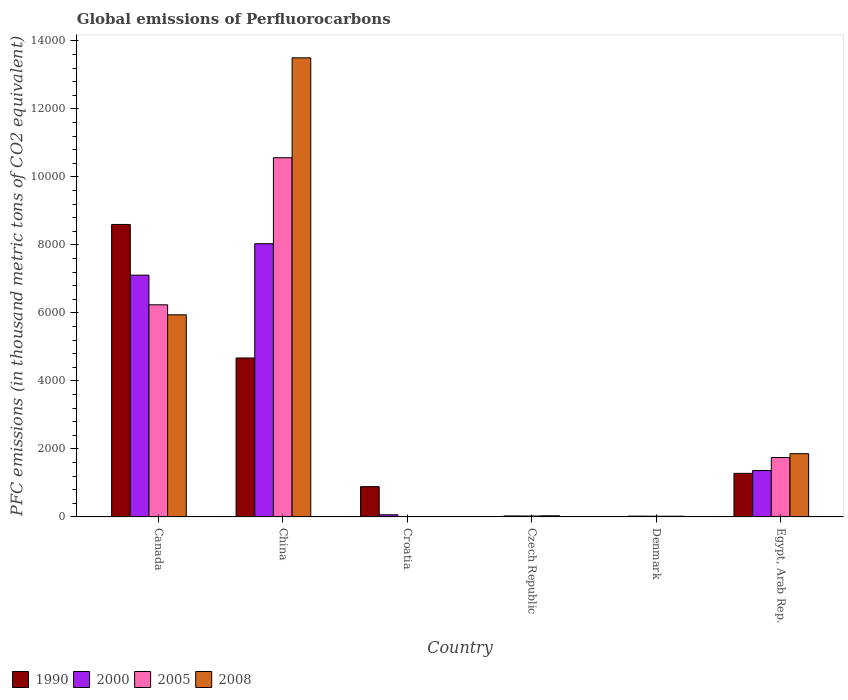How many bars are there on the 3rd tick from the right?
Offer a terse response. 4. What is the label of the 3rd group of bars from the left?
Offer a terse response. Croatia. What is the global emissions of Perfluorocarbons in 1990 in Denmark?
Your response must be concise. 1.4. Across all countries, what is the maximum global emissions of Perfluorocarbons in 2008?
Ensure brevity in your answer.  1.35e+04. In which country was the global emissions of Perfluorocarbons in 2008 minimum?
Offer a very short reply. Croatia. What is the total global emissions of Perfluorocarbons in 2005 in the graph?
Give a very brief answer. 1.86e+04. What is the difference between the global emissions of Perfluorocarbons in 2008 in Croatia and that in Egypt, Arab Rep.?
Your response must be concise. -1848.8. What is the difference between the global emissions of Perfluorocarbons in 2000 in Czech Republic and the global emissions of Perfluorocarbons in 2005 in Egypt, Arab Rep.?
Provide a short and direct response. -1718.3. What is the average global emissions of Perfluorocarbons in 2005 per country?
Your answer should be compact. 3101.3. What is the ratio of the global emissions of Perfluorocarbons in 1990 in Croatia to that in Egypt, Arab Rep.?
Ensure brevity in your answer.  0.7. Is the difference between the global emissions of Perfluorocarbons in 2008 in China and Croatia greater than the difference between the global emissions of Perfluorocarbons in 2000 in China and Croatia?
Provide a succinct answer. Yes. What is the difference between the highest and the second highest global emissions of Perfluorocarbons in 2000?
Your response must be concise. 6670.6. What is the difference between the highest and the lowest global emissions of Perfluorocarbons in 2005?
Provide a short and direct response. 1.06e+04. Is the sum of the global emissions of Perfluorocarbons in 2000 in Czech Republic and Egypt, Arab Rep. greater than the maximum global emissions of Perfluorocarbons in 2005 across all countries?
Keep it short and to the point. No. Is it the case that in every country, the sum of the global emissions of Perfluorocarbons in 2000 and global emissions of Perfluorocarbons in 2008 is greater than the sum of global emissions of Perfluorocarbons in 2005 and global emissions of Perfluorocarbons in 1990?
Your answer should be compact. No. What does the 2nd bar from the right in Denmark represents?
Your response must be concise. 2005. Is it the case that in every country, the sum of the global emissions of Perfluorocarbons in 2005 and global emissions of Perfluorocarbons in 2000 is greater than the global emissions of Perfluorocarbons in 2008?
Provide a short and direct response. Yes. How many bars are there?
Make the answer very short. 24. What is the difference between two consecutive major ticks on the Y-axis?
Ensure brevity in your answer.  2000. Are the values on the major ticks of Y-axis written in scientific E-notation?
Ensure brevity in your answer.  No. Does the graph contain any zero values?
Provide a succinct answer. No. Where does the legend appear in the graph?
Your answer should be very brief. Bottom left. What is the title of the graph?
Provide a succinct answer. Global emissions of Perfluorocarbons. Does "1978" appear as one of the legend labels in the graph?
Give a very brief answer. No. What is the label or title of the Y-axis?
Ensure brevity in your answer.  PFC emissions (in thousand metric tons of CO2 equivalent). What is the PFC emissions (in thousand metric tons of CO2 equivalent) of 1990 in Canada?
Offer a terse response. 8600.3. What is the PFC emissions (in thousand metric tons of CO2 equivalent) of 2000 in Canada?
Provide a short and direct response. 7109.9. What is the PFC emissions (in thousand metric tons of CO2 equivalent) of 2005 in Canada?
Your response must be concise. 6238. What is the PFC emissions (in thousand metric tons of CO2 equivalent) of 2008 in Canada?
Keep it short and to the point. 5943.7. What is the PFC emissions (in thousand metric tons of CO2 equivalent) of 1990 in China?
Ensure brevity in your answer.  4674.5. What is the PFC emissions (in thousand metric tons of CO2 equivalent) in 2000 in China?
Provide a succinct answer. 8034.4. What is the PFC emissions (in thousand metric tons of CO2 equivalent) of 2005 in China?
Offer a terse response. 1.06e+04. What is the PFC emissions (in thousand metric tons of CO2 equivalent) in 2008 in China?
Your answer should be compact. 1.35e+04. What is the PFC emissions (in thousand metric tons of CO2 equivalent) of 1990 in Croatia?
Provide a succinct answer. 890.4. What is the PFC emissions (in thousand metric tons of CO2 equivalent) in 2000 in Croatia?
Your answer should be very brief. 63. What is the PFC emissions (in thousand metric tons of CO2 equivalent) in 2005 in Croatia?
Offer a very short reply. 10.9. What is the PFC emissions (in thousand metric tons of CO2 equivalent) in 1990 in Czech Republic?
Offer a very short reply. 2.8. What is the PFC emissions (in thousand metric tons of CO2 equivalent) of 2000 in Czech Republic?
Your response must be concise. 28.8. What is the PFC emissions (in thousand metric tons of CO2 equivalent) of 2008 in Czech Republic?
Provide a short and direct response. 33.3. What is the PFC emissions (in thousand metric tons of CO2 equivalent) of 1990 in Denmark?
Your answer should be very brief. 1.4. What is the PFC emissions (in thousand metric tons of CO2 equivalent) of 2000 in Denmark?
Provide a short and direct response. 23.4. What is the PFC emissions (in thousand metric tons of CO2 equivalent) of 2008 in Denmark?
Your answer should be compact. 21.4. What is the PFC emissions (in thousand metric tons of CO2 equivalent) in 1990 in Egypt, Arab Rep.?
Your response must be concise. 1280.8. What is the PFC emissions (in thousand metric tons of CO2 equivalent) of 2000 in Egypt, Arab Rep.?
Provide a succinct answer. 1363.8. What is the PFC emissions (in thousand metric tons of CO2 equivalent) in 2005 in Egypt, Arab Rep.?
Give a very brief answer. 1747.1. What is the PFC emissions (in thousand metric tons of CO2 equivalent) in 2008 in Egypt, Arab Rep.?
Provide a short and direct response. 1859.8. Across all countries, what is the maximum PFC emissions (in thousand metric tons of CO2 equivalent) in 1990?
Your answer should be very brief. 8600.3. Across all countries, what is the maximum PFC emissions (in thousand metric tons of CO2 equivalent) in 2000?
Your response must be concise. 8034.4. Across all countries, what is the maximum PFC emissions (in thousand metric tons of CO2 equivalent) in 2005?
Ensure brevity in your answer.  1.06e+04. Across all countries, what is the maximum PFC emissions (in thousand metric tons of CO2 equivalent) in 2008?
Your answer should be compact. 1.35e+04. Across all countries, what is the minimum PFC emissions (in thousand metric tons of CO2 equivalent) of 1990?
Provide a short and direct response. 1.4. Across all countries, what is the minimum PFC emissions (in thousand metric tons of CO2 equivalent) of 2000?
Keep it short and to the point. 23.4. Across all countries, what is the minimum PFC emissions (in thousand metric tons of CO2 equivalent) in 2008?
Your response must be concise. 11. What is the total PFC emissions (in thousand metric tons of CO2 equivalent) of 1990 in the graph?
Provide a short and direct response. 1.55e+04. What is the total PFC emissions (in thousand metric tons of CO2 equivalent) of 2000 in the graph?
Give a very brief answer. 1.66e+04. What is the total PFC emissions (in thousand metric tons of CO2 equivalent) in 2005 in the graph?
Provide a succinct answer. 1.86e+04. What is the total PFC emissions (in thousand metric tons of CO2 equivalent) of 2008 in the graph?
Give a very brief answer. 2.14e+04. What is the difference between the PFC emissions (in thousand metric tons of CO2 equivalent) in 1990 in Canada and that in China?
Your response must be concise. 3925.8. What is the difference between the PFC emissions (in thousand metric tons of CO2 equivalent) in 2000 in Canada and that in China?
Give a very brief answer. -924.5. What is the difference between the PFC emissions (in thousand metric tons of CO2 equivalent) in 2005 in Canada and that in China?
Offer a very short reply. -4324.8. What is the difference between the PFC emissions (in thousand metric tons of CO2 equivalent) of 2008 in Canada and that in China?
Make the answer very short. -7556.9. What is the difference between the PFC emissions (in thousand metric tons of CO2 equivalent) in 1990 in Canada and that in Croatia?
Provide a short and direct response. 7709.9. What is the difference between the PFC emissions (in thousand metric tons of CO2 equivalent) of 2000 in Canada and that in Croatia?
Make the answer very short. 7046.9. What is the difference between the PFC emissions (in thousand metric tons of CO2 equivalent) in 2005 in Canada and that in Croatia?
Provide a short and direct response. 6227.1. What is the difference between the PFC emissions (in thousand metric tons of CO2 equivalent) in 2008 in Canada and that in Croatia?
Provide a succinct answer. 5932.7. What is the difference between the PFC emissions (in thousand metric tons of CO2 equivalent) in 1990 in Canada and that in Czech Republic?
Provide a short and direct response. 8597.5. What is the difference between the PFC emissions (in thousand metric tons of CO2 equivalent) in 2000 in Canada and that in Czech Republic?
Your answer should be very brief. 7081.1. What is the difference between the PFC emissions (in thousand metric tons of CO2 equivalent) in 2005 in Canada and that in Czech Republic?
Provide a short and direct response. 6210.5. What is the difference between the PFC emissions (in thousand metric tons of CO2 equivalent) of 2008 in Canada and that in Czech Republic?
Provide a short and direct response. 5910.4. What is the difference between the PFC emissions (in thousand metric tons of CO2 equivalent) of 1990 in Canada and that in Denmark?
Your answer should be very brief. 8598.9. What is the difference between the PFC emissions (in thousand metric tons of CO2 equivalent) of 2000 in Canada and that in Denmark?
Offer a very short reply. 7086.5. What is the difference between the PFC emissions (in thousand metric tons of CO2 equivalent) in 2005 in Canada and that in Denmark?
Make the answer very short. 6216.5. What is the difference between the PFC emissions (in thousand metric tons of CO2 equivalent) in 2008 in Canada and that in Denmark?
Offer a very short reply. 5922.3. What is the difference between the PFC emissions (in thousand metric tons of CO2 equivalent) in 1990 in Canada and that in Egypt, Arab Rep.?
Provide a short and direct response. 7319.5. What is the difference between the PFC emissions (in thousand metric tons of CO2 equivalent) in 2000 in Canada and that in Egypt, Arab Rep.?
Your answer should be very brief. 5746.1. What is the difference between the PFC emissions (in thousand metric tons of CO2 equivalent) of 2005 in Canada and that in Egypt, Arab Rep.?
Give a very brief answer. 4490.9. What is the difference between the PFC emissions (in thousand metric tons of CO2 equivalent) of 2008 in Canada and that in Egypt, Arab Rep.?
Offer a terse response. 4083.9. What is the difference between the PFC emissions (in thousand metric tons of CO2 equivalent) of 1990 in China and that in Croatia?
Provide a succinct answer. 3784.1. What is the difference between the PFC emissions (in thousand metric tons of CO2 equivalent) in 2000 in China and that in Croatia?
Provide a short and direct response. 7971.4. What is the difference between the PFC emissions (in thousand metric tons of CO2 equivalent) of 2005 in China and that in Croatia?
Ensure brevity in your answer.  1.06e+04. What is the difference between the PFC emissions (in thousand metric tons of CO2 equivalent) of 2008 in China and that in Croatia?
Your answer should be compact. 1.35e+04. What is the difference between the PFC emissions (in thousand metric tons of CO2 equivalent) in 1990 in China and that in Czech Republic?
Provide a succinct answer. 4671.7. What is the difference between the PFC emissions (in thousand metric tons of CO2 equivalent) in 2000 in China and that in Czech Republic?
Provide a short and direct response. 8005.6. What is the difference between the PFC emissions (in thousand metric tons of CO2 equivalent) of 2005 in China and that in Czech Republic?
Offer a very short reply. 1.05e+04. What is the difference between the PFC emissions (in thousand metric tons of CO2 equivalent) in 2008 in China and that in Czech Republic?
Provide a succinct answer. 1.35e+04. What is the difference between the PFC emissions (in thousand metric tons of CO2 equivalent) of 1990 in China and that in Denmark?
Your answer should be compact. 4673.1. What is the difference between the PFC emissions (in thousand metric tons of CO2 equivalent) in 2000 in China and that in Denmark?
Your response must be concise. 8011. What is the difference between the PFC emissions (in thousand metric tons of CO2 equivalent) in 2005 in China and that in Denmark?
Give a very brief answer. 1.05e+04. What is the difference between the PFC emissions (in thousand metric tons of CO2 equivalent) in 2008 in China and that in Denmark?
Your answer should be compact. 1.35e+04. What is the difference between the PFC emissions (in thousand metric tons of CO2 equivalent) in 1990 in China and that in Egypt, Arab Rep.?
Your answer should be compact. 3393.7. What is the difference between the PFC emissions (in thousand metric tons of CO2 equivalent) in 2000 in China and that in Egypt, Arab Rep.?
Provide a short and direct response. 6670.6. What is the difference between the PFC emissions (in thousand metric tons of CO2 equivalent) of 2005 in China and that in Egypt, Arab Rep.?
Offer a terse response. 8815.7. What is the difference between the PFC emissions (in thousand metric tons of CO2 equivalent) in 2008 in China and that in Egypt, Arab Rep.?
Provide a succinct answer. 1.16e+04. What is the difference between the PFC emissions (in thousand metric tons of CO2 equivalent) of 1990 in Croatia and that in Czech Republic?
Provide a short and direct response. 887.6. What is the difference between the PFC emissions (in thousand metric tons of CO2 equivalent) in 2000 in Croatia and that in Czech Republic?
Offer a terse response. 34.2. What is the difference between the PFC emissions (in thousand metric tons of CO2 equivalent) of 2005 in Croatia and that in Czech Republic?
Provide a short and direct response. -16.6. What is the difference between the PFC emissions (in thousand metric tons of CO2 equivalent) in 2008 in Croatia and that in Czech Republic?
Your response must be concise. -22.3. What is the difference between the PFC emissions (in thousand metric tons of CO2 equivalent) in 1990 in Croatia and that in Denmark?
Provide a succinct answer. 889. What is the difference between the PFC emissions (in thousand metric tons of CO2 equivalent) of 2000 in Croatia and that in Denmark?
Your answer should be very brief. 39.6. What is the difference between the PFC emissions (in thousand metric tons of CO2 equivalent) of 2005 in Croatia and that in Denmark?
Offer a terse response. -10.6. What is the difference between the PFC emissions (in thousand metric tons of CO2 equivalent) of 2008 in Croatia and that in Denmark?
Keep it short and to the point. -10.4. What is the difference between the PFC emissions (in thousand metric tons of CO2 equivalent) of 1990 in Croatia and that in Egypt, Arab Rep.?
Keep it short and to the point. -390.4. What is the difference between the PFC emissions (in thousand metric tons of CO2 equivalent) of 2000 in Croatia and that in Egypt, Arab Rep.?
Your answer should be very brief. -1300.8. What is the difference between the PFC emissions (in thousand metric tons of CO2 equivalent) of 2005 in Croatia and that in Egypt, Arab Rep.?
Your response must be concise. -1736.2. What is the difference between the PFC emissions (in thousand metric tons of CO2 equivalent) of 2008 in Croatia and that in Egypt, Arab Rep.?
Keep it short and to the point. -1848.8. What is the difference between the PFC emissions (in thousand metric tons of CO2 equivalent) of 1990 in Czech Republic and that in Egypt, Arab Rep.?
Keep it short and to the point. -1278. What is the difference between the PFC emissions (in thousand metric tons of CO2 equivalent) of 2000 in Czech Republic and that in Egypt, Arab Rep.?
Your answer should be very brief. -1335. What is the difference between the PFC emissions (in thousand metric tons of CO2 equivalent) in 2005 in Czech Republic and that in Egypt, Arab Rep.?
Ensure brevity in your answer.  -1719.6. What is the difference between the PFC emissions (in thousand metric tons of CO2 equivalent) in 2008 in Czech Republic and that in Egypt, Arab Rep.?
Your answer should be very brief. -1826.5. What is the difference between the PFC emissions (in thousand metric tons of CO2 equivalent) of 1990 in Denmark and that in Egypt, Arab Rep.?
Provide a succinct answer. -1279.4. What is the difference between the PFC emissions (in thousand metric tons of CO2 equivalent) of 2000 in Denmark and that in Egypt, Arab Rep.?
Offer a terse response. -1340.4. What is the difference between the PFC emissions (in thousand metric tons of CO2 equivalent) in 2005 in Denmark and that in Egypt, Arab Rep.?
Offer a terse response. -1725.6. What is the difference between the PFC emissions (in thousand metric tons of CO2 equivalent) in 2008 in Denmark and that in Egypt, Arab Rep.?
Provide a short and direct response. -1838.4. What is the difference between the PFC emissions (in thousand metric tons of CO2 equivalent) in 1990 in Canada and the PFC emissions (in thousand metric tons of CO2 equivalent) in 2000 in China?
Keep it short and to the point. 565.9. What is the difference between the PFC emissions (in thousand metric tons of CO2 equivalent) of 1990 in Canada and the PFC emissions (in thousand metric tons of CO2 equivalent) of 2005 in China?
Make the answer very short. -1962.5. What is the difference between the PFC emissions (in thousand metric tons of CO2 equivalent) in 1990 in Canada and the PFC emissions (in thousand metric tons of CO2 equivalent) in 2008 in China?
Your answer should be very brief. -4900.3. What is the difference between the PFC emissions (in thousand metric tons of CO2 equivalent) of 2000 in Canada and the PFC emissions (in thousand metric tons of CO2 equivalent) of 2005 in China?
Offer a terse response. -3452.9. What is the difference between the PFC emissions (in thousand metric tons of CO2 equivalent) in 2000 in Canada and the PFC emissions (in thousand metric tons of CO2 equivalent) in 2008 in China?
Your response must be concise. -6390.7. What is the difference between the PFC emissions (in thousand metric tons of CO2 equivalent) of 2005 in Canada and the PFC emissions (in thousand metric tons of CO2 equivalent) of 2008 in China?
Your answer should be compact. -7262.6. What is the difference between the PFC emissions (in thousand metric tons of CO2 equivalent) of 1990 in Canada and the PFC emissions (in thousand metric tons of CO2 equivalent) of 2000 in Croatia?
Your response must be concise. 8537.3. What is the difference between the PFC emissions (in thousand metric tons of CO2 equivalent) of 1990 in Canada and the PFC emissions (in thousand metric tons of CO2 equivalent) of 2005 in Croatia?
Your answer should be compact. 8589.4. What is the difference between the PFC emissions (in thousand metric tons of CO2 equivalent) in 1990 in Canada and the PFC emissions (in thousand metric tons of CO2 equivalent) in 2008 in Croatia?
Give a very brief answer. 8589.3. What is the difference between the PFC emissions (in thousand metric tons of CO2 equivalent) of 2000 in Canada and the PFC emissions (in thousand metric tons of CO2 equivalent) of 2005 in Croatia?
Provide a succinct answer. 7099. What is the difference between the PFC emissions (in thousand metric tons of CO2 equivalent) of 2000 in Canada and the PFC emissions (in thousand metric tons of CO2 equivalent) of 2008 in Croatia?
Offer a terse response. 7098.9. What is the difference between the PFC emissions (in thousand metric tons of CO2 equivalent) in 2005 in Canada and the PFC emissions (in thousand metric tons of CO2 equivalent) in 2008 in Croatia?
Provide a short and direct response. 6227. What is the difference between the PFC emissions (in thousand metric tons of CO2 equivalent) of 1990 in Canada and the PFC emissions (in thousand metric tons of CO2 equivalent) of 2000 in Czech Republic?
Make the answer very short. 8571.5. What is the difference between the PFC emissions (in thousand metric tons of CO2 equivalent) of 1990 in Canada and the PFC emissions (in thousand metric tons of CO2 equivalent) of 2005 in Czech Republic?
Offer a very short reply. 8572.8. What is the difference between the PFC emissions (in thousand metric tons of CO2 equivalent) of 1990 in Canada and the PFC emissions (in thousand metric tons of CO2 equivalent) of 2008 in Czech Republic?
Keep it short and to the point. 8567. What is the difference between the PFC emissions (in thousand metric tons of CO2 equivalent) in 2000 in Canada and the PFC emissions (in thousand metric tons of CO2 equivalent) in 2005 in Czech Republic?
Make the answer very short. 7082.4. What is the difference between the PFC emissions (in thousand metric tons of CO2 equivalent) in 2000 in Canada and the PFC emissions (in thousand metric tons of CO2 equivalent) in 2008 in Czech Republic?
Your answer should be compact. 7076.6. What is the difference between the PFC emissions (in thousand metric tons of CO2 equivalent) in 2005 in Canada and the PFC emissions (in thousand metric tons of CO2 equivalent) in 2008 in Czech Republic?
Offer a terse response. 6204.7. What is the difference between the PFC emissions (in thousand metric tons of CO2 equivalent) in 1990 in Canada and the PFC emissions (in thousand metric tons of CO2 equivalent) in 2000 in Denmark?
Your answer should be compact. 8576.9. What is the difference between the PFC emissions (in thousand metric tons of CO2 equivalent) of 1990 in Canada and the PFC emissions (in thousand metric tons of CO2 equivalent) of 2005 in Denmark?
Provide a short and direct response. 8578.8. What is the difference between the PFC emissions (in thousand metric tons of CO2 equivalent) in 1990 in Canada and the PFC emissions (in thousand metric tons of CO2 equivalent) in 2008 in Denmark?
Make the answer very short. 8578.9. What is the difference between the PFC emissions (in thousand metric tons of CO2 equivalent) of 2000 in Canada and the PFC emissions (in thousand metric tons of CO2 equivalent) of 2005 in Denmark?
Your answer should be very brief. 7088.4. What is the difference between the PFC emissions (in thousand metric tons of CO2 equivalent) in 2000 in Canada and the PFC emissions (in thousand metric tons of CO2 equivalent) in 2008 in Denmark?
Provide a succinct answer. 7088.5. What is the difference between the PFC emissions (in thousand metric tons of CO2 equivalent) in 2005 in Canada and the PFC emissions (in thousand metric tons of CO2 equivalent) in 2008 in Denmark?
Keep it short and to the point. 6216.6. What is the difference between the PFC emissions (in thousand metric tons of CO2 equivalent) in 1990 in Canada and the PFC emissions (in thousand metric tons of CO2 equivalent) in 2000 in Egypt, Arab Rep.?
Your response must be concise. 7236.5. What is the difference between the PFC emissions (in thousand metric tons of CO2 equivalent) of 1990 in Canada and the PFC emissions (in thousand metric tons of CO2 equivalent) of 2005 in Egypt, Arab Rep.?
Ensure brevity in your answer.  6853.2. What is the difference between the PFC emissions (in thousand metric tons of CO2 equivalent) of 1990 in Canada and the PFC emissions (in thousand metric tons of CO2 equivalent) of 2008 in Egypt, Arab Rep.?
Make the answer very short. 6740.5. What is the difference between the PFC emissions (in thousand metric tons of CO2 equivalent) in 2000 in Canada and the PFC emissions (in thousand metric tons of CO2 equivalent) in 2005 in Egypt, Arab Rep.?
Offer a very short reply. 5362.8. What is the difference between the PFC emissions (in thousand metric tons of CO2 equivalent) in 2000 in Canada and the PFC emissions (in thousand metric tons of CO2 equivalent) in 2008 in Egypt, Arab Rep.?
Provide a short and direct response. 5250.1. What is the difference between the PFC emissions (in thousand metric tons of CO2 equivalent) in 2005 in Canada and the PFC emissions (in thousand metric tons of CO2 equivalent) in 2008 in Egypt, Arab Rep.?
Your answer should be very brief. 4378.2. What is the difference between the PFC emissions (in thousand metric tons of CO2 equivalent) of 1990 in China and the PFC emissions (in thousand metric tons of CO2 equivalent) of 2000 in Croatia?
Make the answer very short. 4611.5. What is the difference between the PFC emissions (in thousand metric tons of CO2 equivalent) of 1990 in China and the PFC emissions (in thousand metric tons of CO2 equivalent) of 2005 in Croatia?
Offer a terse response. 4663.6. What is the difference between the PFC emissions (in thousand metric tons of CO2 equivalent) in 1990 in China and the PFC emissions (in thousand metric tons of CO2 equivalent) in 2008 in Croatia?
Offer a terse response. 4663.5. What is the difference between the PFC emissions (in thousand metric tons of CO2 equivalent) of 2000 in China and the PFC emissions (in thousand metric tons of CO2 equivalent) of 2005 in Croatia?
Your response must be concise. 8023.5. What is the difference between the PFC emissions (in thousand metric tons of CO2 equivalent) in 2000 in China and the PFC emissions (in thousand metric tons of CO2 equivalent) in 2008 in Croatia?
Ensure brevity in your answer.  8023.4. What is the difference between the PFC emissions (in thousand metric tons of CO2 equivalent) of 2005 in China and the PFC emissions (in thousand metric tons of CO2 equivalent) of 2008 in Croatia?
Provide a succinct answer. 1.06e+04. What is the difference between the PFC emissions (in thousand metric tons of CO2 equivalent) in 1990 in China and the PFC emissions (in thousand metric tons of CO2 equivalent) in 2000 in Czech Republic?
Your response must be concise. 4645.7. What is the difference between the PFC emissions (in thousand metric tons of CO2 equivalent) in 1990 in China and the PFC emissions (in thousand metric tons of CO2 equivalent) in 2005 in Czech Republic?
Give a very brief answer. 4647. What is the difference between the PFC emissions (in thousand metric tons of CO2 equivalent) in 1990 in China and the PFC emissions (in thousand metric tons of CO2 equivalent) in 2008 in Czech Republic?
Your answer should be compact. 4641.2. What is the difference between the PFC emissions (in thousand metric tons of CO2 equivalent) of 2000 in China and the PFC emissions (in thousand metric tons of CO2 equivalent) of 2005 in Czech Republic?
Offer a terse response. 8006.9. What is the difference between the PFC emissions (in thousand metric tons of CO2 equivalent) in 2000 in China and the PFC emissions (in thousand metric tons of CO2 equivalent) in 2008 in Czech Republic?
Your answer should be very brief. 8001.1. What is the difference between the PFC emissions (in thousand metric tons of CO2 equivalent) of 2005 in China and the PFC emissions (in thousand metric tons of CO2 equivalent) of 2008 in Czech Republic?
Offer a very short reply. 1.05e+04. What is the difference between the PFC emissions (in thousand metric tons of CO2 equivalent) in 1990 in China and the PFC emissions (in thousand metric tons of CO2 equivalent) in 2000 in Denmark?
Keep it short and to the point. 4651.1. What is the difference between the PFC emissions (in thousand metric tons of CO2 equivalent) in 1990 in China and the PFC emissions (in thousand metric tons of CO2 equivalent) in 2005 in Denmark?
Keep it short and to the point. 4653. What is the difference between the PFC emissions (in thousand metric tons of CO2 equivalent) in 1990 in China and the PFC emissions (in thousand metric tons of CO2 equivalent) in 2008 in Denmark?
Provide a succinct answer. 4653.1. What is the difference between the PFC emissions (in thousand metric tons of CO2 equivalent) in 2000 in China and the PFC emissions (in thousand metric tons of CO2 equivalent) in 2005 in Denmark?
Give a very brief answer. 8012.9. What is the difference between the PFC emissions (in thousand metric tons of CO2 equivalent) of 2000 in China and the PFC emissions (in thousand metric tons of CO2 equivalent) of 2008 in Denmark?
Ensure brevity in your answer.  8013. What is the difference between the PFC emissions (in thousand metric tons of CO2 equivalent) in 2005 in China and the PFC emissions (in thousand metric tons of CO2 equivalent) in 2008 in Denmark?
Your answer should be very brief. 1.05e+04. What is the difference between the PFC emissions (in thousand metric tons of CO2 equivalent) in 1990 in China and the PFC emissions (in thousand metric tons of CO2 equivalent) in 2000 in Egypt, Arab Rep.?
Give a very brief answer. 3310.7. What is the difference between the PFC emissions (in thousand metric tons of CO2 equivalent) of 1990 in China and the PFC emissions (in thousand metric tons of CO2 equivalent) of 2005 in Egypt, Arab Rep.?
Provide a succinct answer. 2927.4. What is the difference between the PFC emissions (in thousand metric tons of CO2 equivalent) of 1990 in China and the PFC emissions (in thousand metric tons of CO2 equivalent) of 2008 in Egypt, Arab Rep.?
Ensure brevity in your answer.  2814.7. What is the difference between the PFC emissions (in thousand metric tons of CO2 equivalent) of 2000 in China and the PFC emissions (in thousand metric tons of CO2 equivalent) of 2005 in Egypt, Arab Rep.?
Ensure brevity in your answer.  6287.3. What is the difference between the PFC emissions (in thousand metric tons of CO2 equivalent) of 2000 in China and the PFC emissions (in thousand metric tons of CO2 equivalent) of 2008 in Egypt, Arab Rep.?
Ensure brevity in your answer.  6174.6. What is the difference between the PFC emissions (in thousand metric tons of CO2 equivalent) in 2005 in China and the PFC emissions (in thousand metric tons of CO2 equivalent) in 2008 in Egypt, Arab Rep.?
Your answer should be very brief. 8703. What is the difference between the PFC emissions (in thousand metric tons of CO2 equivalent) of 1990 in Croatia and the PFC emissions (in thousand metric tons of CO2 equivalent) of 2000 in Czech Republic?
Provide a succinct answer. 861.6. What is the difference between the PFC emissions (in thousand metric tons of CO2 equivalent) of 1990 in Croatia and the PFC emissions (in thousand metric tons of CO2 equivalent) of 2005 in Czech Republic?
Your response must be concise. 862.9. What is the difference between the PFC emissions (in thousand metric tons of CO2 equivalent) in 1990 in Croatia and the PFC emissions (in thousand metric tons of CO2 equivalent) in 2008 in Czech Republic?
Offer a terse response. 857.1. What is the difference between the PFC emissions (in thousand metric tons of CO2 equivalent) in 2000 in Croatia and the PFC emissions (in thousand metric tons of CO2 equivalent) in 2005 in Czech Republic?
Your answer should be compact. 35.5. What is the difference between the PFC emissions (in thousand metric tons of CO2 equivalent) of 2000 in Croatia and the PFC emissions (in thousand metric tons of CO2 equivalent) of 2008 in Czech Republic?
Keep it short and to the point. 29.7. What is the difference between the PFC emissions (in thousand metric tons of CO2 equivalent) in 2005 in Croatia and the PFC emissions (in thousand metric tons of CO2 equivalent) in 2008 in Czech Republic?
Give a very brief answer. -22.4. What is the difference between the PFC emissions (in thousand metric tons of CO2 equivalent) in 1990 in Croatia and the PFC emissions (in thousand metric tons of CO2 equivalent) in 2000 in Denmark?
Ensure brevity in your answer.  867. What is the difference between the PFC emissions (in thousand metric tons of CO2 equivalent) of 1990 in Croatia and the PFC emissions (in thousand metric tons of CO2 equivalent) of 2005 in Denmark?
Offer a terse response. 868.9. What is the difference between the PFC emissions (in thousand metric tons of CO2 equivalent) in 1990 in Croatia and the PFC emissions (in thousand metric tons of CO2 equivalent) in 2008 in Denmark?
Your response must be concise. 869. What is the difference between the PFC emissions (in thousand metric tons of CO2 equivalent) of 2000 in Croatia and the PFC emissions (in thousand metric tons of CO2 equivalent) of 2005 in Denmark?
Your answer should be very brief. 41.5. What is the difference between the PFC emissions (in thousand metric tons of CO2 equivalent) of 2000 in Croatia and the PFC emissions (in thousand metric tons of CO2 equivalent) of 2008 in Denmark?
Your answer should be compact. 41.6. What is the difference between the PFC emissions (in thousand metric tons of CO2 equivalent) of 1990 in Croatia and the PFC emissions (in thousand metric tons of CO2 equivalent) of 2000 in Egypt, Arab Rep.?
Make the answer very short. -473.4. What is the difference between the PFC emissions (in thousand metric tons of CO2 equivalent) in 1990 in Croatia and the PFC emissions (in thousand metric tons of CO2 equivalent) in 2005 in Egypt, Arab Rep.?
Offer a terse response. -856.7. What is the difference between the PFC emissions (in thousand metric tons of CO2 equivalent) of 1990 in Croatia and the PFC emissions (in thousand metric tons of CO2 equivalent) of 2008 in Egypt, Arab Rep.?
Ensure brevity in your answer.  -969.4. What is the difference between the PFC emissions (in thousand metric tons of CO2 equivalent) of 2000 in Croatia and the PFC emissions (in thousand metric tons of CO2 equivalent) of 2005 in Egypt, Arab Rep.?
Your answer should be compact. -1684.1. What is the difference between the PFC emissions (in thousand metric tons of CO2 equivalent) in 2000 in Croatia and the PFC emissions (in thousand metric tons of CO2 equivalent) in 2008 in Egypt, Arab Rep.?
Offer a very short reply. -1796.8. What is the difference between the PFC emissions (in thousand metric tons of CO2 equivalent) of 2005 in Croatia and the PFC emissions (in thousand metric tons of CO2 equivalent) of 2008 in Egypt, Arab Rep.?
Give a very brief answer. -1848.9. What is the difference between the PFC emissions (in thousand metric tons of CO2 equivalent) in 1990 in Czech Republic and the PFC emissions (in thousand metric tons of CO2 equivalent) in 2000 in Denmark?
Offer a very short reply. -20.6. What is the difference between the PFC emissions (in thousand metric tons of CO2 equivalent) in 1990 in Czech Republic and the PFC emissions (in thousand metric tons of CO2 equivalent) in 2005 in Denmark?
Make the answer very short. -18.7. What is the difference between the PFC emissions (in thousand metric tons of CO2 equivalent) in 1990 in Czech Republic and the PFC emissions (in thousand metric tons of CO2 equivalent) in 2008 in Denmark?
Provide a succinct answer. -18.6. What is the difference between the PFC emissions (in thousand metric tons of CO2 equivalent) of 1990 in Czech Republic and the PFC emissions (in thousand metric tons of CO2 equivalent) of 2000 in Egypt, Arab Rep.?
Give a very brief answer. -1361. What is the difference between the PFC emissions (in thousand metric tons of CO2 equivalent) of 1990 in Czech Republic and the PFC emissions (in thousand metric tons of CO2 equivalent) of 2005 in Egypt, Arab Rep.?
Give a very brief answer. -1744.3. What is the difference between the PFC emissions (in thousand metric tons of CO2 equivalent) of 1990 in Czech Republic and the PFC emissions (in thousand metric tons of CO2 equivalent) of 2008 in Egypt, Arab Rep.?
Offer a very short reply. -1857. What is the difference between the PFC emissions (in thousand metric tons of CO2 equivalent) of 2000 in Czech Republic and the PFC emissions (in thousand metric tons of CO2 equivalent) of 2005 in Egypt, Arab Rep.?
Provide a succinct answer. -1718.3. What is the difference between the PFC emissions (in thousand metric tons of CO2 equivalent) of 2000 in Czech Republic and the PFC emissions (in thousand metric tons of CO2 equivalent) of 2008 in Egypt, Arab Rep.?
Make the answer very short. -1831. What is the difference between the PFC emissions (in thousand metric tons of CO2 equivalent) in 2005 in Czech Republic and the PFC emissions (in thousand metric tons of CO2 equivalent) in 2008 in Egypt, Arab Rep.?
Give a very brief answer. -1832.3. What is the difference between the PFC emissions (in thousand metric tons of CO2 equivalent) of 1990 in Denmark and the PFC emissions (in thousand metric tons of CO2 equivalent) of 2000 in Egypt, Arab Rep.?
Your answer should be very brief. -1362.4. What is the difference between the PFC emissions (in thousand metric tons of CO2 equivalent) of 1990 in Denmark and the PFC emissions (in thousand metric tons of CO2 equivalent) of 2005 in Egypt, Arab Rep.?
Provide a short and direct response. -1745.7. What is the difference between the PFC emissions (in thousand metric tons of CO2 equivalent) in 1990 in Denmark and the PFC emissions (in thousand metric tons of CO2 equivalent) in 2008 in Egypt, Arab Rep.?
Provide a succinct answer. -1858.4. What is the difference between the PFC emissions (in thousand metric tons of CO2 equivalent) in 2000 in Denmark and the PFC emissions (in thousand metric tons of CO2 equivalent) in 2005 in Egypt, Arab Rep.?
Offer a very short reply. -1723.7. What is the difference between the PFC emissions (in thousand metric tons of CO2 equivalent) of 2000 in Denmark and the PFC emissions (in thousand metric tons of CO2 equivalent) of 2008 in Egypt, Arab Rep.?
Ensure brevity in your answer.  -1836.4. What is the difference between the PFC emissions (in thousand metric tons of CO2 equivalent) in 2005 in Denmark and the PFC emissions (in thousand metric tons of CO2 equivalent) in 2008 in Egypt, Arab Rep.?
Make the answer very short. -1838.3. What is the average PFC emissions (in thousand metric tons of CO2 equivalent) of 1990 per country?
Your response must be concise. 2575.03. What is the average PFC emissions (in thousand metric tons of CO2 equivalent) of 2000 per country?
Make the answer very short. 2770.55. What is the average PFC emissions (in thousand metric tons of CO2 equivalent) in 2005 per country?
Offer a terse response. 3101.3. What is the average PFC emissions (in thousand metric tons of CO2 equivalent) in 2008 per country?
Provide a short and direct response. 3561.63. What is the difference between the PFC emissions (in thousand metric tons of CO2 equivalent) in 1990 and PFC emissions (in thousand metric tons of CO2 equivalent) in 2000 in Canada?
Provide a succinct answer. 1490.4. What is the difference between the PFC emissions (in thousand metric tons of CO2 equivalent) in 1990 and PFC emissions (in thousand metric tons of CO2 equivalent) in 2005 in Canada?
Provide a short and direct response. 2362.3. What is the difference between the PFC emissions (in thousand metric tons of CO2 equivalent) in 1990 and PFC emissions (in thousand metric tons of CO2 equivalent) in 2008 in Canada?
Make the answer very short. 2656.6. What is the difference between the PFC emissions (in thousand metric tons of CO2 equivalent) in 2000 and PFC emissions (in thousand metric tons of CO2 equivalent) in 2005 in Canada?
Your answer should be very brief. 871.9. What is the difference between the PFC emissions (in thousand metric tons of CO2 equivalent) of 2000 and PFC emissions (in thousand metric tons of CO2 equivalent) of 2008 in Canada?
Offer a terse response. 1166.2. What is the difference between the PFC emissions (in thousand metric tons of CO2 equivalent) of 2005 and PFC emissions (in thousand metric tons of CO2 equivalent) of 2008 in Canada?
Your answer should be very brief. 294.3. What is the difference between the PFC emissions (in thousand metric tons of CO2 equivalent) in 1990 and PFC emissions (in thousand metric tons of CO2 equivalent) in 2000 in China?
Provide a short and direct response. -3359.9. What is the difference between the PFC emissions (in thousand metric tons of CO2 equivalent) in 1990 and PFC emissions (in thousand metric tons of CO2 equivalent) in 2005 in China?
Make the answer very short. -5888.3. What is the difference between the PFC emissions (in thousand metric tons of CO2 equivalent) in 1990 and PFC emissions (in thousand metric tons of CO2 equivalent) in 2008 in China?
Your answer should be very brief. -8826.1. What is the difference between the PFC emissions (in thousand metric tons of CO2 equivalent) in 2000 and PFC emissions (in thousand metric tons of CO2 equivalent) in 2005 in China?
Give a very brief answer. -2528.4. What is the difference between the PFC emissions (in thousand metric tons of CO2 equivalent) in 2000 and PFC emissions (in thousand metric tons of CO2 equivalent) in 2008 in China?
Offer a terse response. -5466.2. What is the difference between the PFC emissions (in thousand metric tons of CO2 equivalent) of 2005 and PFC emissions (in thousand metric tons of CO2 equivalent) of 2008 in China?
Keep it short and to the point. -2937.8. What is the difference between the PFC emissions (in thousand metric tons of CO2 equivalent) in 1990 and PFC emissions (in thousand metric tons of CO2 equivalent) in 2000 in Croatia?
Ensure brevity in your answer.  827.4. What is the difference between the PFC emissions (in thousand metric tons of CO2 equivalent) in 1990 and PFC emissions (in thousand metric tons of CO2 equivalent) in 2005 in Croatia?
Your response must be concise. 879.5. What is the difference between the PFC emissions (in thousand metric tons of CO2 equivalent) in 1990 and PFC emissions (in thousand metric tons of CO2 equivalent) in 2008 in Croatia?
Offer a very short reply. 879.4. What is the difference between the PFC emissions (in thousand metric tons of CO2 equivalent) of 2000 and PFC emissions (in thousand metric tons of CO2 equivalent) of 2005 in Croatia?
Make the answer very short. 52.1. What is the difference between the PFC emissions (in thousand metric tons of CO2 equivalent) of 1990 and PFC emissions (in thousand metric tons of CO2 equivalent) of 2000 in Czech Republic?
Offer a very short reply. -26. What is the difference between the PFC emissions (in thousand metric tons of CO2 equivalent) in 1990 and PFC emissions (in thousand metric tons of CO2 equivalent) in 2005 in Czech Republic?
Offer a terse response. -24.7. What is the difference between the PFC emissions (in thousand metric tons of CO2 equivalent) of 1990 and PFC emissions (in thousand metric tons of CO2 equivalent) of 2008 in Czech Republic?
Give a very brief answer. -30.5. What is the difference between the PFC emissions (in thousand metric tons of CO2 equivalent) in 2000 and PFC emissions (in thousand metric tons of CO2 equivalent) in 2005 in Czech Republic?
Offer a terse response. 1.3. What is the difference between the PFC emissions (in thousand metric tons of CO2 equivalent) of 2005 and PFC emissions (in thousand metric tons of CO2 equivalent) of 2008 in Czech Republic?
Provide a succinct answer. -5.8. What is the difference between the PFC emissions (in thousand metric tons of CO2 equivalent) of 1990 and PFC emissions (in thousand metric tons of CO2 equivalent) of 2005 in Denmark?
Offer a very short reply. -20.1. What is the difference between the PFC emissions (in thousand metric tons of CO2 equivalent) of 1990 and PFC emissions (in thousand metric tons of CO2 equivalent) of 2008 in Denmark?
Offer a terse response. -20. What is the difference between the PFC emissions (in thousand metric tons of CO2 equivalent) of 2000 and PFC emissions (in thousand metric tons of CO2 equivalent) of 2005 in Denmark?
Your response must be concise. 1.9. What is the difference between the PFC emissions (in thousand metric tons of CO2 equivalent) of 2005 and PFC emissions (in thousand metric tons of CO2 equivalent) of 2008 in Denmark?
Give a very brief answer. 0.1. What is the difference between the PFC emissions (in thousand metric tons of CO2 equivalent) in 1990 and PFC emissions (in thousand metric tons of CO2 equivalent) in 2000 in Egypt, Arab Rep.?
Your answer should be very brief. -83. What is the difference between the PFC emissions (in thousand metric tons of CO2 equivalent) of 1990 and PFC emissions (in thousand metric tons of CO2 equivalent) of 2005 in Egypt, Arab Rep.?
Offer a very short reply. -466.3. What is the difference between the PFC emissions (in thousand metric tons of CO2 equivalent) in 1990 and PFC emissions (in thousand metric tons of CO2 equivalent) in 2008 in Egypt, Arab Rep.?
Ensure brevity in your answer.  -579. What is the difference between the PFC emissions (in thousand metric tons of CO2 equivalent) of 2000 and PFC emissions (in thousand metric tons of CO2 equivalent) of 2005 in Egypt, Arab Rep.?
Your response must be concise. -383.3. What is the difference between the PFC emissions (in thousand metric tons of CO2 equivalent) in 2000 and PFC emissions (in thousand metric tons of CO2 equivalent) in 2008 in Egypt, Arab Rep.?
Give a very brief answer. -496. What is the difference between the PFC emissions (in thousand metric tons of CO2 equivalent) of 2005 and PFC emissions (in thousand metric tons of CO2 equivalent) of 2008 in Egypt, Arab Rep.?
Make the answer very short. -112.7. What is the ratio of the PFC emissions (in thousand metric tons of CO2 equivalent) of 1990 in Canada to that in China?
Give a very brief answer. 1.84. What is the ratio of the PFC emissions (in thousand metric tons of CO2 equivalent) in 2000 in Canada to that in China?
Make the answer very short. 0.88. What is the ratio of the PFC emissions (in thousand metric tons of CO2 equivalent) in 2005 in Canada to that in China?
Give a very brief answer. 0.59. What is the ratio of the PFC emissions (in thousand metric tons of CO2 equivalent) of 2008 in Canada to that in China?
Your response must be concise. 0.44. What is the ratio of the PFC emissions (in thousand metric tons of CO2 equivalent) of 1990 in Canada to that in Croatia?
Keep it short and to the point. 9.66. What is the ratio of the PFC emissions (in thousand metric tons of CO2 equivalent) in 2000 in Canada to that in Croatia?
Ensure brevity in your answer.  112.86. What is the ratio of the PFC emissions (in thousand metric tons of CO2 equivalent) of 2005 in Canada to that in Croatia?
Provide a short and direct response. 572.29. What is the ratio of the PFC emissions (in thousand metric tons of CO2 equivalent) of 2008 in Canada to that in Croatia?
Make the answer very short. 540.34. What is the ratio of the PFC emissions (in thousand metric tons of CO2 equivalent) in 1990 in Canada to that in Czech Republic?
Offer a very short reply. 3071.54. What is the ratio of the PFC emissions (in thousand metric tons of CO2 equivalent) of 2000 in Canada to that in Czech Republic?
Your answer should be very brief. 246.87. What is the ratio of the PFC emissions (in thousand metric tons of CO2 equivalent) in 2005 in Canada to that in Czech Republic?
Your response must be concise. 226.84. What is the ratio of the PFC emissions (in thousand metric tons of CO2 equivalent) in 2008 in Canada to that in Czech Republic?
Offer a very short reply. 178.49. What is the ratio of the PFC emissions (in thousand metric tons of CO2 equivalent) of 1990 in Canada to that in Denmark?
Your answer should be compact. 6143.07. What is the ratio of the PFC emissions (in thousand metric tons of CO2 equivalent) of 2000 in Canada to that in Denmark?
Offer a very short reply. 303.84. What is the ratio of the PFC emissions (in thousand metric tons of CO2 equivalent) in 2005 in Canada to that in Denmark?
Provide a short and direct response. 290.14. What is the ratio of the PFC emissions (in thousand metric tons of CO2 equivalent) of 2008 in Canada to that in Denmark?
Offer a very short reply. 277.74. What is the ratio of the PFC emissions (in thousand metric tons of CO2 equivalent) of 1990 in Canada to that in Egypt, Arab Rep.?
Provide a short and direct response. 6.71. What is the ratio of the PFC emissions (in thousand metric tons of CO2 equivalent) of 2000 in Canada to that in Egypt, Arab Rep.?
Offer a terse response. 5.21. What is the ratio of the PFC emissions (in thousand metric tons of CO2 equivalent) of 2005 in Canada to that in Egypt, Arab Rep.?
Keep it short and to the point. 3.57. What is the ratio of the PFC emissions (in thousand metric tons of CO2 equivalent) in 2008 in Canada to that in Egypt, Arab Rep.?
Your response must be concise. 3.2. What is the ratio of the PFC emissions (in thousand metric tons of CO2 equivalent) of 1990 in China to that in Croatia?
Your answer should be very brief. 5.25. What is the ratio of the PFC emissions (in thousand metric tons of CO2 equivalent) of 2000 in China to that in Croatia?
Provide a short and direct response. 127.53. What is the ratio of the PFC emissions (in thousand metric tons of CO2 equivalent) in 2005 in China to that in Croatia?
Keep it short and to the point. 969.06. What is the ratio of the PFC emissions (in thousand metric tons of CO2 equivalent) in 2008 in China to that in Croatia?
Ensure brevity in your answer.  1227.33. What is the ratio of the PFC emissions (in thousand metric tons of CO2 equivalent) in 1990 in China to that in Czech Republic?
Keep it short and to the point. 1669.46. What is the ratio of the PFC emissions (in thousand metric tons of CO2 equivalent) in 2000 in China to that in Czech Republic?
Provide a succinct answer. 278.97. What is the ratio of the PFC emissions (in thousand metric tons of CO2 equivalent) of 2005 in China to that in Czech Republic?
Provide a succinct answer. 384.1. What is the ratio of the PFC emissions (in thousand metric tons of CO2 equivalent) in 2008 in China to that in Czech Republic?
Make the answer very short. 405.42. What is the ratio of the PFC emissions (in thousand metric tons of CO2 equivalent) of 1990 in China to that in Denmark?
Make the answer very short. 3338.93. What is the ratio of the PFC emissions (in thousand metric tons of CO2 equivalent) in 2000 in China to that in Denmark?
Your answer should be compact. 343.35. What is the ratio of the PFC emissions (in thousand metric tons of CO2 equivalent) in 2005 in China to that in Denmark?
Give a very brief answer. 491.29. What is the ratio of the PFC emissions (in thousand metric tons of CO2 equivalent) in 2008 in China to that in Denmark?
Ensure brevity in your answer.  630.87. What is the ratio of the PFC emissions (in thousand metric tons of CO2 equivalent) in 1990 in China to that in Egypt, Arab Rep.?
Your answer should be very brief. 3.65. What is the ratio of the PFC emissions (in thousand metric tons of CO2 equivalent) of 2000 in China to that in Egypt, Arab Rep.?
Offer a very short reply. 5.89. What is the ratio of the PFC emissions (in thousand metric tons of CO2 equivalent) in 2005 in China to that in Egypt, Arab Rep.?
Provide a short and direct response. 6.05. What is the ratio of the PFC emissions (in thousand metric tons of CO2 equivalent) of 2008 in China to that in Egypt, Arab Rep.?
Your response must be concise. 7.26. What is the ratio of the PFC emissions (in thousand metric tons of CO2 equivalent) in 1990 in Croatia to that in Czech Republic?
Your response must be concise. 318. What is the ratio of the PFC emissions (in thousand metric tons of CO2 equivalent) of 2000 in Croatia to that in Czech Republic?
Provide a succinct answer. 2.19. What is the ratio of the PFC emissions (in thousand metric tons of CO2 equivalent) in 2005 in Croatia to that in Czech Republic?
Make the answer very short. 0.4. What is the ratio of the PFC emissions (in thousand metric tons of CO2 equivalent) in 2008 in Croatia to that in Czech Republic?
Your response must be concise. 0.33. What is the ratio of the PFC emissions (in thousand metric tons of CO2 equivalent) of 1990 in Croatia to that in Denmark?
Provide a succinct answer. 636. What is the ratio of the PFC emissions (in thousand metric tons of CO2 equivalent) of 2000 in Croatia to that in Denmark?
Give a very brief answer. 2.69. What is the ratio of the PFC emissions (in thousand metric tons of CO2 equivalent) of 2005 in Croatia to that in Denmark?
Offer a terse response. 0.51. What is the ratio of the PFC emissions (in thousand metric tons of CO2 equivalent) in 2008 in Croatia to that in Denmark?
Keep it short and to the point. 0.51. What is the ratio of the PFC emissions (in thousand metric tons of CO2 equivalent) in 1990 in Croatia to that in Egypt, Arab Rep.?
Provide a short and direct response. 0.7. What is the ratio of the PFC emissions (in thousand metric tons of CO2 equivalent) in 2000 in Croatia to that in Egypt, Arab Rep.?
Offer a very short reply. 0.05. What is the ratio of the PFC emissions (in thousand metric tons of CO2 equivalent) of 2005 in Croatia to that in Egypt, Arab Rep.?
Ensure brevity in your answer.  0.01. What is the ratio of the PFC emissions (in thousand metric tons of CO2 equivalent) in 2008 in Croatia to that in Egypt, Arab Rep.?
Offer a terse response. 0.01. What is the ratio of the PFC emissions (in thousand metric tons of CO2 equivalent) of 2000 in Czech Republic to that in Denmark?
Your answer should be very brief. 1.23. What is the ratio of the PFC emissions (in thousand metric tons of CO2 equivalent) of 2005 in Czech Republic to that in Denmark?
Ensure brevity in your answer.  1.28. What is the ratio of the PFC emissions (in thousand metric tons of CO2 equivalent) of 2008 in Czech Republic to that in Denmark?
Your answer should be very brief. 1.56. What is the ratio of the PFC emissions (in thousand metric tons of CO2 equivalent) in 1990 in Czech Republic to that in Egypt, Arab Rep.?
Give a very brief answer. 0. What is the ratio of the PFC emissions (in thousand metric tons of CO2 equivalent) in 2000 in Czech Republic to that in Egypt, Arab Rep.?
Offer a very short reply. 0.02. What is the ratio of the PFC emissions (in thousand metric tons of CO2 equivalent) of 2005 in Czech Republic to that in Egypt, Arab Rep.?
Ensure brevity in your answer.  0.02. What is the ratio of the PFC emissions (in thousand metric tons of CO2 equivalent) in 2008 in Czech Republic to that in Egypt, Arab Rep.?
Offer a very short reply. 0.02. What is the ratio of the PFC emissions (in thousand metric tons of CO2 equivalent) in 1990 in Denmark to that in Egypt, Arab Rep.?
Ensure brevity in your answer.  0. What is the ratio of the PFC emissions (in thousand metric tons of CO2 equivalent) of 2000 in Denmark to that in Egypt, Arab Rep.?
Provide a succinct answer. 0.02. What is the ratio of the PFC emissions (in thousand metric tons of CO2 equivalent) of 2005 in Denmark to that in Egypt, Arab Rep.?
Your response must be concise. 0.01. What is the ratio of the PFC emissions (in thousand metric tons of CO2 equivalent) of 2008 in Denmark to that in Egypt, Arab Rep.?
Offer a terse response. 0.01. What is the difference between the highest and the second highest PFC emissions (in thousand metric tons of CO2 equivalent) of 1990?
Your response must be concise. 3925.8. What is the difference between the highest and the second highest PFC emissions (in thousand metric tons of CO2 equivalent) in 2000?
Your response must be concise. 924.5. What is the difference between the highest and the second highest PFC emissions (in thousand metric tons of CO2 equivalent) in 2005?
Give a very brief answer. 4324.8. What is the difference between the highest and the second highest PFC emissions (in thousand metric tons of CO2 equivalent) in 2008?
Provide a succinct answer. 7556.9. What is the difference between the highest and the lowest PFC emissions (in thousand metric tons of CO2 equivalent) of 1990?
Provide a short and direct response. 8598.9. What is the difference between the highest and the lowest PFC emissions (in thousand metric tons of CO2 equivalent) of 2000?
Provide a short and direct response. 8011. What is the difference between the highest and the lowest PFC emissions (in thousand metric tons of CO2 equivalent) in 2005?
Offer a very short reply. 1.06e+04. What is the difference between the highest and the lowest PFC emissions (in thousand metric tons of CO2 equivalent) in 2008?
Offer a terse response. 1.35e+04. 